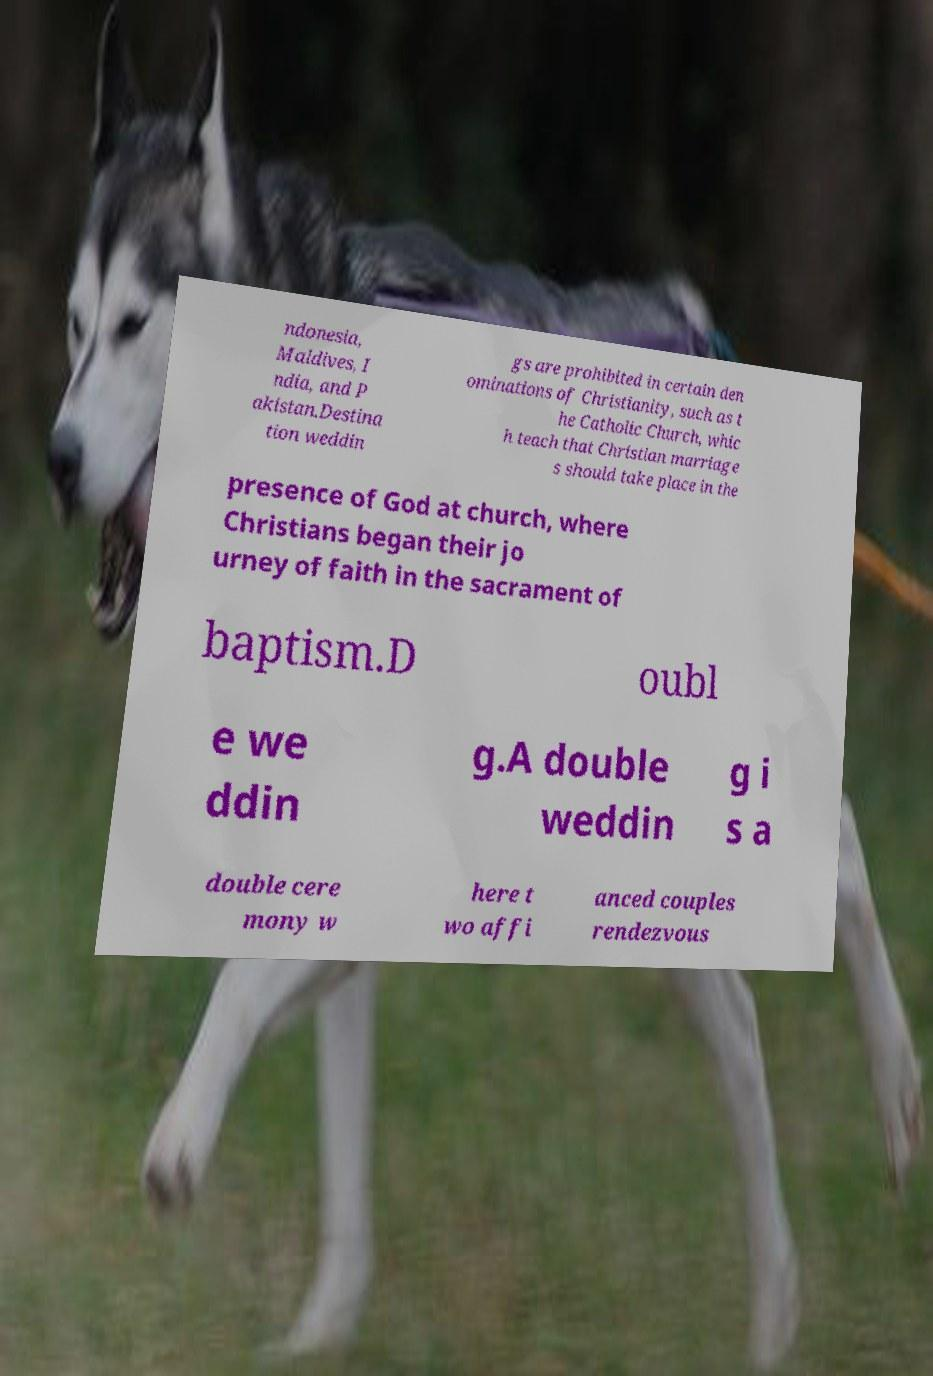There's text embedded in this image that I need extracted. Can you transcribe it verbatim? ndonesia, Maldives, I ndia, and P akistan.Destina tion weddin gs are prohibited in certain den ominations of Christianity, such as t he Catholic Church, whic h teach that Christian marriage s should take place in the presence of God at church, where Christians began their jo urney of faith in the sacrament of baptism.D oubl e we ddin g.A double weddin g i s a double cere mony w here t wo affi anced couples rendezvous 